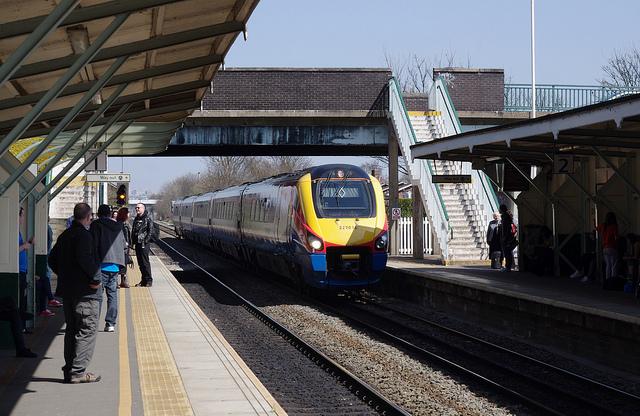How many people are waiting for the train?
Answer briefly. 4. How many colors are on the train?
Concise answer only. 3. According to the signs, which side is number 2?
Short answer required. Right. 